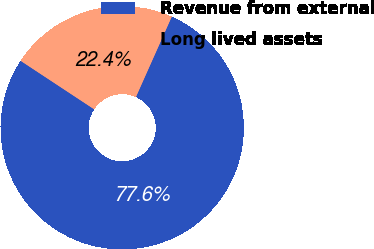<chart> <loc_0><loc_0><loc_500><loc_500><pie_chart><fcel>Revenue from external<fcel>Long lived assets<nl><fcel>77.6%<fcel>22.4%<nl></chart> 